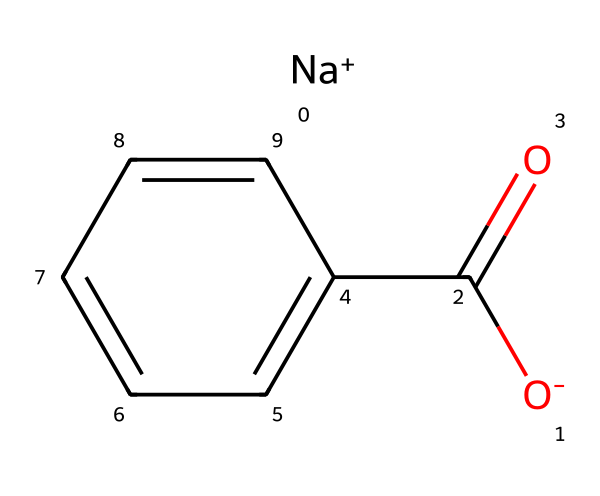What is the molecular formula of sodium benzoate? From the SMILES representation, we can identify the elements present: sodium (Na), carbon (C), oxygen (O), and hydrogen (H). The structure indicates one sodium ion, seven carbons, and two oxygens (from the carboxylate group). Therefore, the molecular formula is C7H5NaO2.
Answer: C7H5NaO2 How many carbon atoms are in sodium benzoate? By examining the structure, we see there are seven carbon atoms present. The six carbon atoms in the benzene ring and one carbon in the carboxylate group contribute to the total count.
Answer: 7 What type of bond connects sodium to the rest of sodium benzoate? The sodium ion is held by an ionic bond to the carboxylate group, which is negatively charged. This ionic interaction is due to the attraction between the positively charged sodium ion and the negatively charged carboxylate ion.
Answer: ionic bond Does sodium benzoate contain any aromatic rings? The presence of the benzene structure in the SMILES indicates an aromatic ring. A benzene ring consists of six carbon atoms connected with alternating double bonds, confirming that sodium benzoate contains an aromatic ring.
Answer: yes What functional group is present in sodium benzoate? The SMILES representation shows a carboxylate (–COO–) functional group that is characteristic of sodium benzoate. This functional group is formed from the carboxylic acid by deprotonation of the acidic hydrogen.
Answer: carboxylate Why is sodium benzoate effective as a preservative? Sodium benzoate acts as a preservative due to its ability to inhibit the growth of fungi and yeast. This inhibition is largely attributed to its ionic form, which can enter microbial cells and disrupt metabolic processes, thus extending the shelf life of food and beverages.
Answer: inhibits microbial growth 